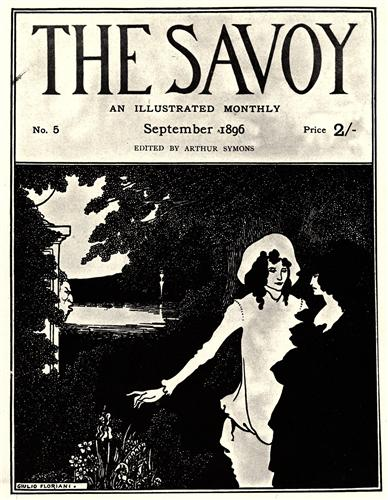What emotions do you think the couple is experiencing? The couple in the image appears to be experiencing a blend of tranquility and romantic connection. The woman's serene expression and the protective posture of the man suggest a deep sense of calm and mutual affection. The serene garden and flowing river backdrop further enhance the peaceful and romantic mood. How does the garden setting contribute to the overall mood of the scene? The garden setting plays a crucial role in establishing the overall mood of the scene. The lush foliage and the river flowing gently in the background create a sense of peace and serenity, enhancing the tranquil and romantic atmosphere between the couple. The natural beauty of the garden, in its monochromatic palette, adds an element of timelessness and elegance to the image, making the scene appear almost dreamlike. 